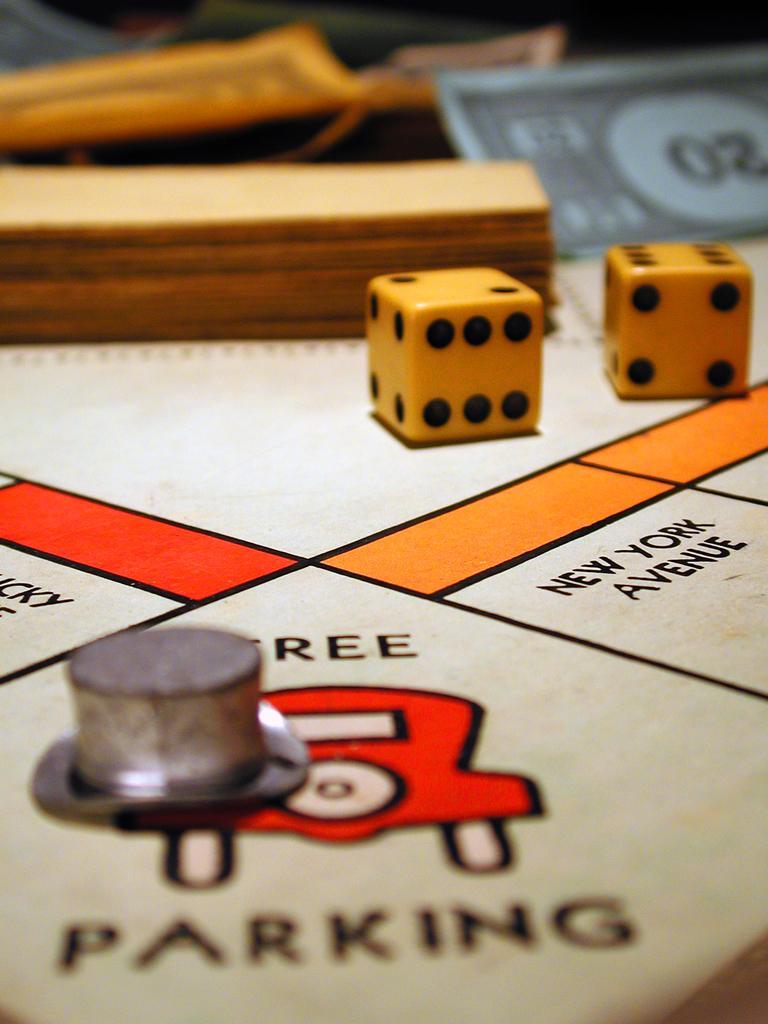Could you give a brief overview of what you see in this image? In this image we can see two dice, a currency note, some papers and an object placed on the surface with some text and drawing. 